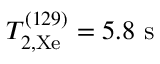<formula> <loc_0><loc_0><loc_500><loc_500>T _ { 2 , X e } ^ { ( 1 2 9 ) } = 5 . 8 s</formula> 